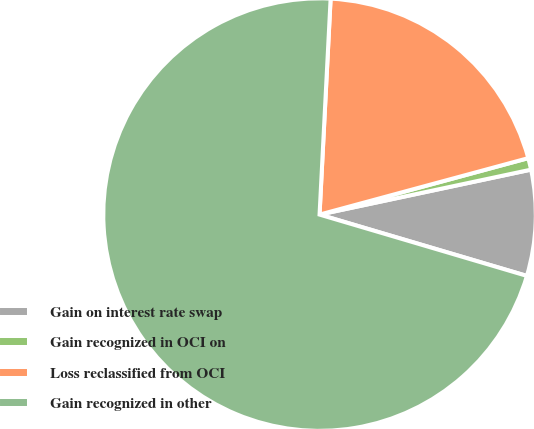Convert chart. <chart><loc_0><loc_0><loc_500><loc_500><pie_chart><fcel>Gain on interest rate swap<fcel>Gain recognized in OCI on<fcel>Loss reclassified from OCI<fcel>Gain recognized in other<nl><fcel>7.91%<fcel>0.87%<fcel>19.98%<fcel>71.24%<nl></chart> 